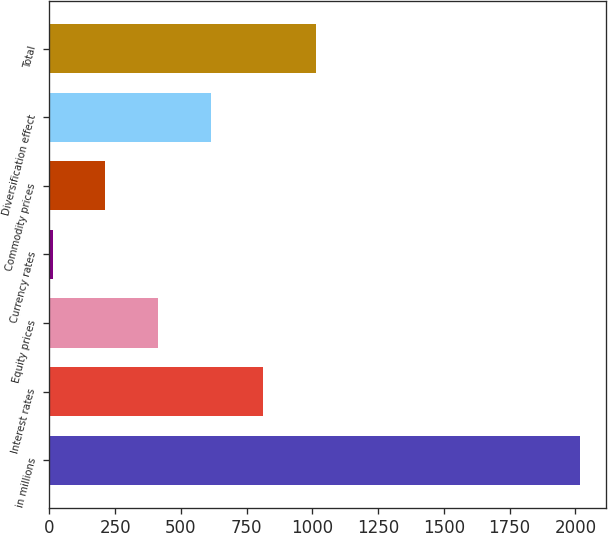Convert chart. <chart><loc_0><loc_0><loc_500><loc_500><bar_chart><fcel>in millions<fcel>Interest rates<fcel>Equity prices<fcel>Currency rates<fcel>Commodity prices<fcel>Diversification effect<fcel>Total<nl><fcel>2017<fcel>814<fcel>413<fcel>12<fcel>212.5<fcel>613.5<fcel>1014.5<nl></chart> 